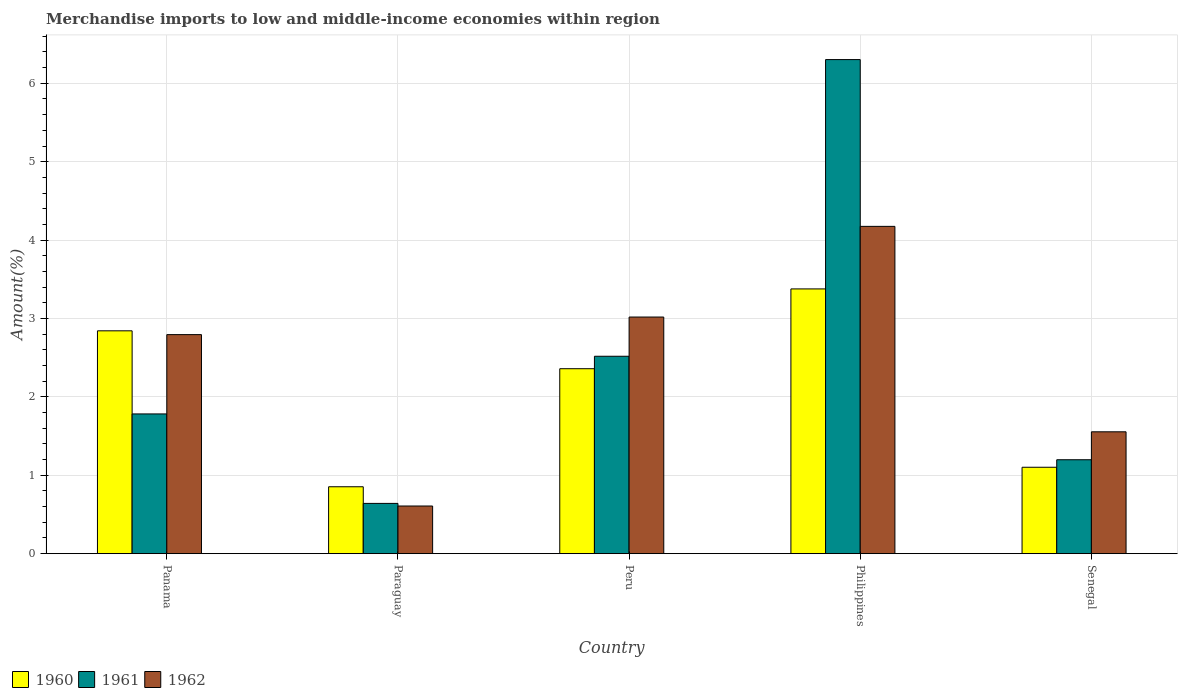How many different coloured bars are there?
Offer a very short reply. 3. How many groups of bars are there?
Provide a short and direct response. 5. How many bars are there on the 4th tick from the left?
Offer a very short reply. 3. What is the label of the 4th group of bars from the left?
Keep it short and to the point. Philippines. What is the percentage of amount earned from merchandise imports in 1961 in Panama?
Give a very brief answer. 1.78. Across all countries, what is the maximum percentage of amount earned from merchandise imports in 1961?
Provide a short and direct response. 6.3. Across all countries, what is the minimum percentage of amount earned from merchandise imports in 1960?
Your answer should be very brief. 0.85. In which country was the percentage of amount earned from merchandise imports in 1960 minimum?
Make the answer very short. Paraguay. What is the total percentage of amount earned from merchandise imports in 1962 in the graph?
Keep it short and to the point. 12.15. What is the difference between the percentage of amount earned from merchandise imports in 1961 in Panama and that in Senegal?
Provide a short and direct response. 0.58. What is the difference between the percentage of amount earned from merchandise imports in 1960 in Paraguay and the percentage of amount earned from merchandise imports in 1962 in Philippines?
Give a very brief answer. -3.32. What is the average percentage of amount earned from merchandise imports in 1962 per country?
Ensure brevity in your answer.  2.43. What is the difference between the percentage of amount earned from merchandise imports of/in 1962 and percentage of amount earned from merchandise imports of/in 1960 in Senegal?
Ensure brevity in your answer.  0.45. In how many countries, is the percentage of amount earned from merchandise imports in 1962 greater than 5.2 %?
Keep it short and to the point. 0. What is the ratio of the percentage of amount earned from merchandise imports in 1961 in Peru to that in Senegal?
Make the answer very short. 2.1. Is the difference between the percentage of amount earned from merchandise imports in 1962 in Paraguay and Senegal greater than the difference between the percentage of amount earned from merchandise imports in 1960 in Paraguay and Senegal?
Offer a very short reply. No. What is the difference between the highest and the second highest percentage of amount earned from merchandise imports in 1961?
Provide a short and direct response. -0.74. What is the difference between the highest and the lowest percentage of amount earned from merchandise imports in 1962?
Keep it short and to the point. 3.57. In how many countries, is the percentage of amount earned from merchandise imports in 1960 greater than the average percentage of amount earned from merchandise imports in 1960 taken over all countries?
Ensure brevity in your answer.  3. Is the sum of the percentage of amount earned from merchandise imports in 1960 in Paraguay and Philippines greater than the maximum percentage of amount earned from merchandise imports in 1962 across all countries?
Give a very brief answer. Yes. What does the 3rd bar from the right in Philippines represents?
Your response must be concise. 1960. Are all the bars in the graph horizontal?
Your response must be concise. No. How many countries are there in the graph?
Offer a very short reply. 5. What is the difference between two consecutive major ticks on the Y-axis?
Your answer should be compact. 1. Does the graph contain grids?
Ensure brevity in your answer.  Yes. Where does the legend appear in the graph?
Your response must be concise. Bottom left. How are the legend labels stacked?
Ensure brevity in your answer.  Horizontal. What is the title of the graph?
Provide a succinct answer. Merchandise imports to low and middle-income economies within region. Does "2000" appear as one of the legend labels in the graph?
Make the answer very short. No. What is the label or title of the Y-axis?
Your answer should be compact. Amount(%). What is the Amount(%) of 1960 in Panama?
Your answer should be very brief. 2.84. What is the Amount(%) of 1961 in Panama?
Ensure brevity in your answer.  1.78. What is the Amount(%) of 1962 in Panama?
Your answer should be very brief. 2.79. What is the Amount(%) in 1960 in Paraguay?
Your answer should be compact. 0.85. What is the Amount(%) of 1961 in Paraguay?
Provide a succinct answer. 0.64. What is the Amount(%) in 1962 in Paraguay?
Give a very brief answer. 0.61. What is the Amount(%) of 1960 in Peru?
Your answer should be very brief. 2.36. What is the Amount(%) in 1961 in Peru?
Keep it short and to the point. 2.52. What is the Amount(%) in 1962 in Peru?
Your response must be concise. 3.02. What is the Amount(%) of 1960 in Philippines?
Provide a short and direct response. 3.38. What is the Amount(%) of 1961 in Philippines?
Ensure brevity in your answer.  6.3. What is the Amount(%) of 1962 in Philippines?
Your answer should be compact. 4.18. What is the Amount(%) of 1960 in Senegal?
Provide a succinct answer. 1.1. What is the Amount(%) in 1961 in Senegal?
Your answer should be compact. 1.2. What is the Amount(%) of 1962 in Senegal?
Your response must be concise. 1.55. Across all countries, what is the maximum Amount(%) of 1960?
Offer a very short reply. 3.38. Across all countries, what is the maximum Amount(%) in 1961?
Offer a very short reply. 6.3. Across all countries, what is the maximum Amount(%) of 1962?
Offer a very short reply. 4.18. Across all countries, what is the minimum Amount(%) of 1960?
Make the answer very short. 0.85. Across all countries, what is the minimum Amount(%) in 1961?
Give a very brief answer. 0.64. Across all countries, what is the minimum Amount(%) in 1962?
Give a very brief answer. 0.61. What is the total Amount(%) of 1960 in the graph?
Keep it short and to the point. 10.53. What is the total Amount(%) in 1961 in the graph?
Your answer should be very brief. 12.44. What is the total Amount(%) of 1962 in the graph?
Provide a short and direct response. 12.15. What is the difference between the Amount(%) of 1960 in Panama and that in Paraguay?
Your answer should be very brief. 1.99. What is the difference between the Amount(%) of 1961 in Panama and that in Paraguay?
Your response must be concise. 1.14. What is the difference between the Amount(%) in 1962 in Panama and that in Paraguay?
Your response must be concise. 2.19. What is the difference between the Amount(%) of 1960 in Panama and that in Peru?
Give a very brief answer. 0.48. What is the difference between the Amount(%) of 1961 in Panama and that in Peru?
Make the answer very short. -0.74. What is the difference between the Amount(%) of 1962 in Panama and that in Peru?
Provide a short and direct response. -0.22. What is the difference between the Amount(%) of 1960 in Panama and that in Philippines?
Offer a very short reply. -0.53. What is the difference between the Amount(%) of 1961 in Panama and that in Philippines?
Ensure brevity in your answer.  -4.52. What is the difference between the Amount(%) of 1962 in Panama and that in Philippines?
Provide a succinct answer. -1.38. What is the difference between the Amount(%) in 1960 in Panama and that in Senegal?
Provide a short and direct response. 1.74. What is the difference between the Amount(%) in 1961 in Panama and that in Senegal?
Offer a very short reply. 0.58. What is the difference between the Amount(%) in 1962 in Panama and that in Senegal?
Your answer should be compact. 1.24. What is the difference between the Amount(%) of 1960 in Paraguay and that in Peru?
Your response must be concise. -1.51. What is the difference between the Amount(%) of 1961 in Paraguay and that in Peru?
Your response must be concise. -1.88. What is the difference between the Amount(%) in 1962 in Paraguay and that in Peru?
Give a very brief answer. -2.41. What is the difference between the Amount(%) in 1960 in Paraguay and that in Philippines?
Your answer should be very brief. -2.52. What is the difference between the Amount(%) in 1961 in Paraguay and that in Philippines?
Offer a terse response. -5.66. What is the difference between the Amount(%) in 1962 in Paraguay and that in Philippines?
Make the answer very short. -3.57. What is the difference between the Amount(%) in 1960 in Paraguay and that in Senegal?
Make the answer very short. -0.25. What is the difference between the Amount(%) in 1961 in Paraguay and that in Senegal?
Offer a terse response. -0.56. What is the difference between the Amount(%) in 1962 in Paraguay and that in Senegal?
Your answer should be very brief. -0.95. What is the difference between the Amount(%) in 1960 in Peru and that in Philippines?
Make the answer very short. -1.02. What is the difference between the Amount(%) of 1961 in Peru and that in Philippines?
Keep it short and to the point. -3.78. What is the difference between the Amount(%) of 1962 in Peru and that in Philippines?
Your answer should be very brief. -1.16. What is the difference between the Amount(%) in 1960 in Peru and that in Senegal?
Make the answer very short. 1.26. What is the difference between the Amount(%) of 1961 in Peru and that in Senegal?
Provide a short and direct response. 1.32. What is the difference between the Amount(%) of 1962 in Peru and that in Senegal?
Provide a succinct answer. 1.46. What is the difference between the Amount(%) in 1960 in Philippines and that in Senegal?
Offer a terse response. 2.28. What is the difference between the Amount(%) of 1961 in Philippines and that in Senegal?
Your answer should be very brief. 5.1. What is the difference between the Amount(%) in 1962 in Philippines and that in Senegal?
Keep it short and to the point. 2.62. What is the difference between the Amount(%) of 1960 in Panama and the Amount(%) of 1961 in Paraguay?
Offer a terse response. 2.2. What is the difference between the Amount(%) in 1960 in Panama and the Amount(%) in 1962 in Paraguay?
Give a very brief answer. 2.23. What is the difference between the Amount(%) in 1961 in Panama and the Amount(%) in 1962 in Paraguay?
Give a very brief answer. 1.17. What is the difference between the Amount(%) in 1960 in Panama and the Amount(%) in 1961 in Peru?
Ensure brevity in your answer.  0.32. What is the difference between the Amount(%) in 1960 in Panama and the Amount(%) in 1962 in Peru?
Give a very brief answer. -0.18. What is the difference between the Amount(%) of 1961 in Panama and the Amount(%) of 1962 in Peru?
Your answer should be compact. -1.24. What is the difference between the Amount(%) of 1960 in Panama and the Amount(%) of 1961 in Philippines?
Make the answer very short. -3.46. What is the difference between the Amount(%) in 1960 in Panama and the Amount(%) in 1962 in Philippines?
Your response must be concise. -1.33. What is the difference between the Amount(%) in 1961 in Panama and the Amount(%) in 1962 in Philippines?
Keep it short and to the point. -2.39. What is the difference between the Amount(%) in 1960 in Panama and the Amount(%) in 1961 in Senegal?
Make the answer very short. 1.64. What is the difference between the Amount(%) of 1960 in Panama and the Amount(%) of 1962 in Senegal?
Offer a very short reply. 1.29. What is the difference between the Amount(%) of 1961 in Panama and the Amount(%) of 1962 in Senegal?
Your response must be concise. 0.23. What is the difference between the Amount(%) in 1960 in Paraguay and the Amount(%) in 1961 in Peru?
Offer a terse response. -1.66. What is the difference between the Amount(%) of 1960 in Paraguay and the Amount(%) of 1962 in Peru?
Your answer should be very brief. -2.17. What is the difference between the Amount(%) of 1961 in Paraguay and the Amount(%) of 1962 in Peru?
Make the answer very short. -2.38. What is the difference between the Amount(%) in 1960 in Paraguay and the Amount(%) in 1961 in Philippines?
Ensure brevity in your answer.  -5.45. What is the difference between the Amount(%) in 1960 in Paraguay and the Amount(%) in 1962 in Philippines?
Provide a succinct answer. -3.32. What is the difference between the Amount(%) in 1961 in Paraguay and the Amount(%) in 1962 in Philippines?
Make the answer very short. -3.53. What is the difference between the Amount(%) of 1960 in Paraguay and the Amount(%) of 1961 in Senegal?
Give a very brief answer. -0.34. What is the difference between the Amount(%) in 1960 in Paraguay and the Amount(%) in 1962 in Senegal?
Your response must be concise. -0.7. What is the difference between the Amount(%) in 1961 in Paraguay and the Amount(%) in 1962 in Senegal?
Your response must be concise. -0.91. What is the difference between the Amount(%) of 1960 in Peru and the Amount(%) of 1961 in Philippines?
Ensure brevity in your answer.  -3.94. What is the difference between the Amount(%) of 1960 in Peru and the Amount(%) of 1962 in Philippines?
Ensure brevity in your answer.  -1.82. What is the difference between the Amount(%) of 1961 in Peru and the Amount(%) of 1962 in Philippines?
Your answer should be very brief. -1.66. What is the difference between the Amount(%) in 1960 in Peru and the Amount(%) in 1961 in Senegal?
Make the answer very short. 1.16. What is the difference between the Amount(%) of 1960 in Peru and the Amount(%) of 1962 in Senegal?
Offer a terse response. 0.8. What is the difference between the Amount(%) in 1961 in Peru and the Amount(%) in 1962 in Senegal?
Your answer should be compact. 0.96. What is the difference between the Amount(%) in 1960 in Philippines and the Amount(%) in 1961 in Senegal?
Keep it short and to the point. 2.18. What is the difference between the Amount(%) of 1960 in Philippines and the Amount(%) of 1962 in Senegal?
Your response must be concise. 1.82. What is the difference between the Amount(%) of 1961 in Philippines and the Amount(%) of 1962 in Senegal?
Ensure brevity in your answer.  4.75. What is the average Amount(%) in 1960 per country?
Your response must be concise. 2.11. What is the average Amount(%) in 1961 per country?
Offer a very short reply. 2.49. What is the average Amount(%) of 1962 per country?
Provide a short and direct response. 2.43. What is the difference between the Amount(%) in 1960 and Amount(%) in 1961 in Panama?
Your answer should be very brief. 1.06. What is the difference between the Amount(%) in 1960 and Amount(%) in 1962 in Panama?
Ensure brevity in your answer.  0.05. What is the difference between the Amount(%) in 1961 and Amount(%) in 1962 in Panama?
Give a very brief answer. -1.01. What is the difference between the Amount(%) in 1960 and Amount(%) in 1961 in Paraguay?
Offer a terse response. 0.21. What is the difference between the Amount(%) in 1960 and Amount(%) in 1962 in Paraguay?
Offer a terse response. 0.25. What is the difference between the Amount(%) of 1961 and Amount(%) of 1962 in Paraguay?
Give a very brief answer. 0.03. What is the difference between the Amount(%) of 1960 and Amount(%) of 1961 in Peru?
Make the answer very short. -0.16. What is the difference between the Amount(%) of 1960 and Amount(%) of 1962 in Peru?
Give a very brief answer. -0.66. What is the difference between the Amount(%) in 1961 and Amount(%) in 1962 in Peru?
Keep it short and to the point. -0.5. What is the difference between the Amount(%) of 1960 and Amount(%) of 1961 in Philippines?
Your answer should be compact. -2.93. What is the difference between the Amount(%) of 1960 and Amount(%) of 1962 in Philippines?
Make the answer very short. -0.8. What is the difference between the Amount(%) of 1961 and Amount(%) of 1962 in Philippines?
Offer a terse response. 2.13. What is the difference between the Amount(%) of 1960 and Amount(%) of 1961 in Senegal?
Offer a very short reply. -0.1. What is the difference between the Amount(%) in 1960 and Amount(%) in 1962 in Senegal?
Your answer should be very brief. -0.45. What is the difference between the Amount(%) in 1961 and Amount(%) in 1962 in Senegal?
Offer a terse response. -0.36. What is the ratio of the Amount(%) of 1960 in Panama to that in Paraguay?
Provide a short and direct response. 3.33. What is the ratio of the Amount(%) of 1961 in Panama to that in Paraguay?
Your response must be concise. 2.78. What is the ratio of the Amount(%) of 1962 in Panama to that in Paraguay?
Your answer should be very brief. 4.6. What is the ratio of the Amount(%) of 1960 in Panama to that in Peru?
Your answer should be very brief. 1.2. What is the ratio of the Amount(%) in 1961 in Panama to that in Peru?
Offer a very short reply. 0.71. What is the ratio of the Amount(%) in 1962 in Panama to that in Peru?
Provide a short and direct response. 0.93. What is the ratio of the Amount(%) in 1960 in Panama to that in Philippines?
Keep it short and to the point. 0.84. What is the ratio of the Amount(%) in 1961 in Panama to that in Philippines?
Your answer should be compact. 0.28. What is the ratio of the Amount(%) in 1962 in Panama to that in Philippines?
Provide a short and direct response. 0.67. What is the ratio of the Amount(%) of 1960 in Panama to that in Senegal?
Your answer should be very brief. 2.58. What is the ratio of the Amount(%) of 1961 in Panama to that in Senegal?
Make the answer very short. 1.49. What is the ratio of the Amount(%) of 1962 in Panama to that in Senegal?
Offer a very short reply. 1.8. What is the ratio of the Amount(%) of 1960 in Paraguay to that in Peru?
Give a very brief answer. 0.36. What is the ratio of the Amount(%) of 1961 in Paraguay to that in Peru?
Keep it short and to the point. 0.25. What is the ratio of the Amount(%) in 1962 in Paraguay to that in Peru?
Keep it short and to the point. 0.2. What is the ratio of the Amount(%) in 1960 in Paraguay to that in Philippines?
Offer a terse response. 0.25. What is the ratio of the Amount(%) in 1961 in Paraguay to that in Philippines?
Your answer should be very brief. 0.1. What is the ratio of the Amount(%) of 1962 in Paraguay to that in Philippines?
Your response must be concise. 0.15. What is the ratio of the Amount(%) in 1960 in Paraguay to that in Senegal?
Offer a terse response. 0.77. What is the ratio of the Amount(%) of 1961 in Paraguay to that in Senegal?
Your answer should be very brief. 0.54. What is the ratio of the Amount(%) in 1962 in Paraguay to that in Senegal?
Make the answer very short. 0.39. What is the ratio of the Amount(%) in 1960 in Peru to that in Philippines?
Give a very brief answer. 0.7. What is the ratio of the Amount(%) of 1961 in Peru to that in Philippines?
Provide a short and direct response. 0.4. What is the ratio of the Amount(%) in 1962 in Peru to that in Philippines?
Your answer should be very brief. 0.72. What is the ratio of the Amount(%) in 1960 in Peru to that in Senegal?
Make the answer very short. 2.14. What is the ratio of the Amount(%) of 1961 in Peru to that in Senegal?
Your answer should be very brief. 2.1. What is the ratio of the Amount(%) of 1962 in Peru to that in Senegal?
Keep it short and to the point. 1.94. What is the ratio of the Amount(%) in 1960 in Philippines to that in Senegal?
Your answer should be compact. 3.06. What is the ratio of the Amount(%) in 1961 in Philippines to that in Senegal?
Your answer should be very brief. 5.26. What is the ratio of the Amount(%) of 1962 in Philippines to that in Senegal?
Give a very brief answer. 2.69. What is the difference between the highest and the second highest Amount(%) of 1960?
Keep it short and to the point. 0.53. What is the difference between the highest and the second highest Amount(%) of 1961?
Provide a succinct answer. 3.78. What is the difference between the highest and the second highest Amount(%) of 1962?
Your response must be concise. 1.16. What is the difference between the highest and the lowest Amount(%) in 1960?
Your answer should be compact. 2.52. What is the difference between the highest and the lowest Amount(%) in 1961?
Your answer should be compact. 5.66. What is the difference between the highest and the lowest Amount(%) in 1962?
Your answer should be very brief. 3.57. 